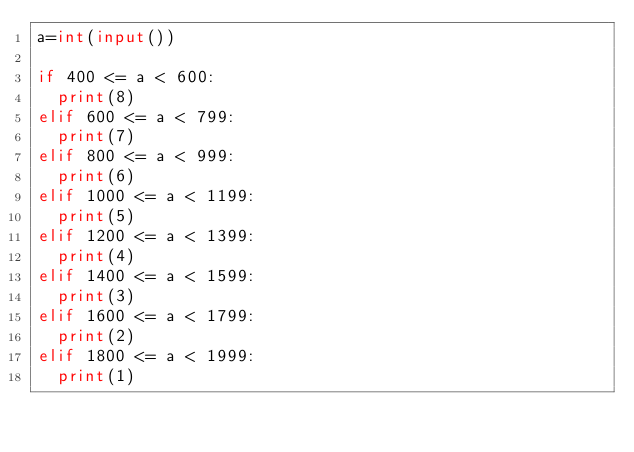<code> <loc_0><loc_0><loc_500><loc_500><_Python_>a=int(input())	

if 400 <= a < 600:
  print(8)
elif 600 <= a < 799:
  print(7)
elif 800 <= a < 999:
  print(6)
elif 1000 <= a < 1199:
  print(5)
elif 1200 <= a < 1399:
  print(4)
elif 1400 <= a < 1599:
  print(3)
elif 1600 <= a < 1799:
  print(2)
elif 1800 <= a < 1999:
  print(1)</code> 